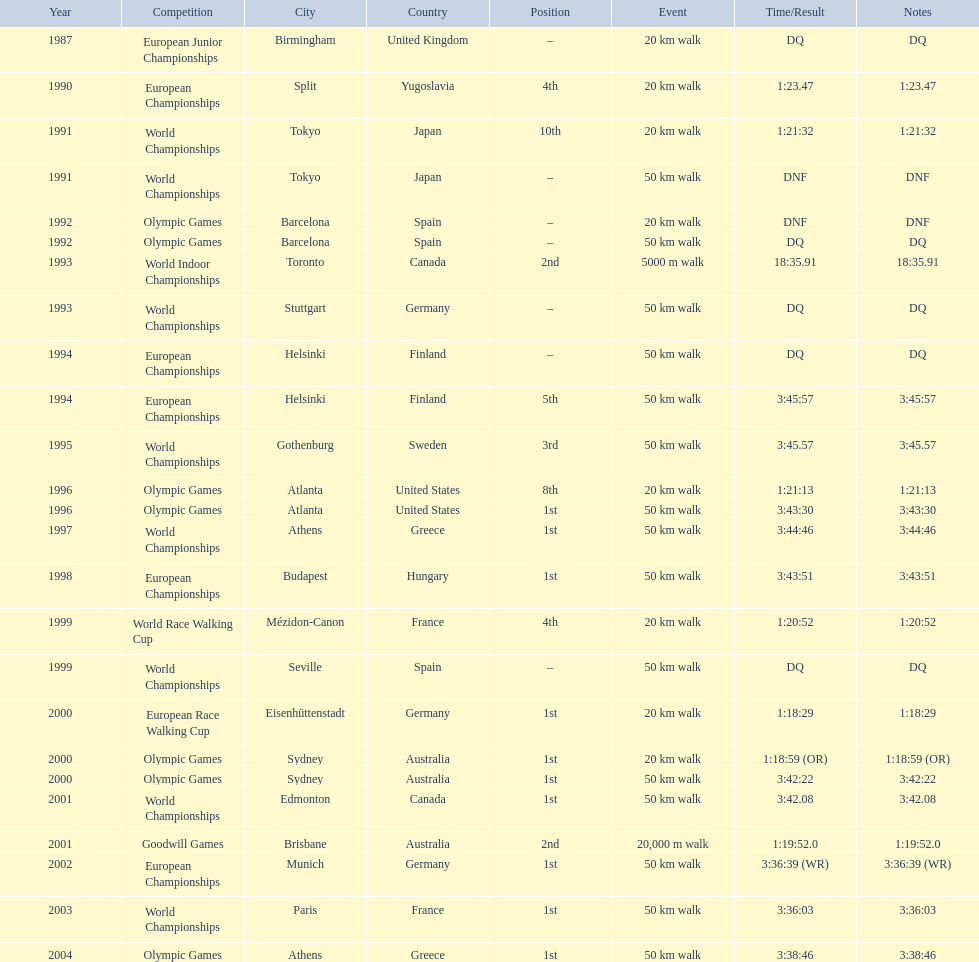In 1990 what position did robert korzeniowski place? 4th. In 1993 what was robert korzeniowski's place in the world indoor championships? 2nd. How long did the 50km walk in 2004 olympic cost? 3:38:46. 